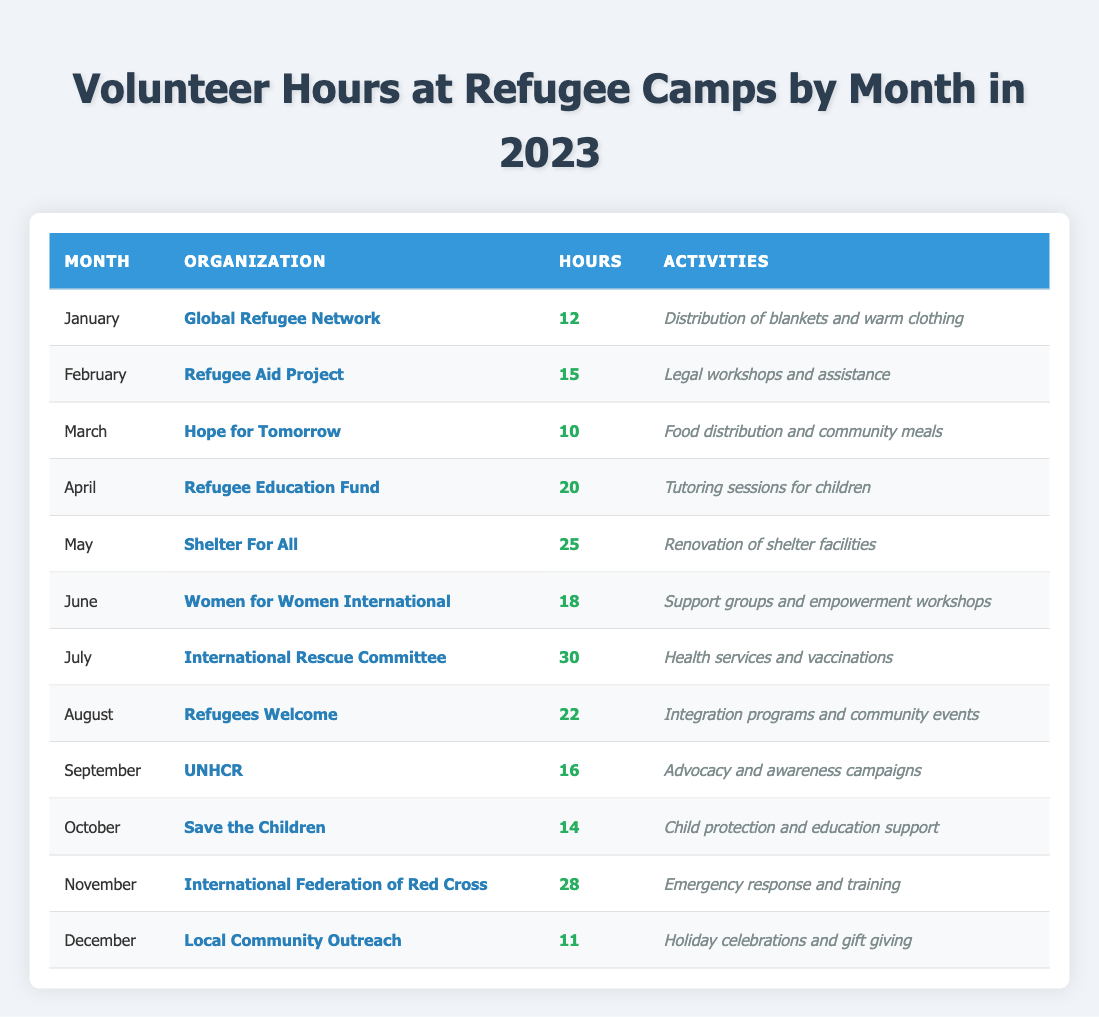What are the total volunteer hours contributed in July? In July, the volunteer hours contributed were 30.
Answer: 30 Which organization did I volunteer for in November? In November, I volunteered for the International Federation of Red Cross.
Answer: International Federation of Red Cross What activities were conducted in April? In April, the activities included tutoring sessions for children.
Answer: Tutoring sessions for children How many hours did I volunteer in May compared to June? I volunteered for 25 hours in May and 18 hours in June, which is a difference of 7 hours.
Answer: 7 hours What is the total number of volunteer hours for the first half of the year (January to June)? The total hours from January (12) + February (15) + March (10) + April (20) + May (25) + June (18) equals 110 hours.
Answer: 110 hours Did I volunteer more hours in August than in any other month except July? In August, I volunteered for 22 hours, which is less than the 30 hours in July and more than any month besides that, thus the statement is true.
Answer: Yes Which month had the least amount of volunteer hours, and what were those hours? The month with the least amount of volunteer hours was March with 10 hours.
Answer: March, 10 hours What is the average number of volunteer hours per month for the entire year? The total hours for the year are 12 + 15 + 10 + 20 + 25 + 18 + 30 + 22 + 16 + 14 + 28 + 11 =  10 + 15 + 12 + 10 + 20 + 25 + 18 + 30 + 22 + 16 + 14 + 28 + 11 =  294 hours. Then divide by 12 (months) gives 294 / 12 = 24.5 hours/month.
Answer: 24.5 hours In which month did I contribute the highest number of hours, and what was the organization? The highest number of hours was contributed in July with 30 hours for the International Rescue Committee.
Answer: July, International Rescue Committee Are the volunteer activities consistent in terms of community support throughout the year? Evaluating the activities, they are centered around support and assistance which reflects consistency in community support across the year.
Answer: Yes What was the total number of volunteer hours during the second half of the year (July to December)? The total hours from July (30) + August (22) + September (16) + October (14) + November (28) + December (11) equals 121 hours.
Answer: 121 hours 